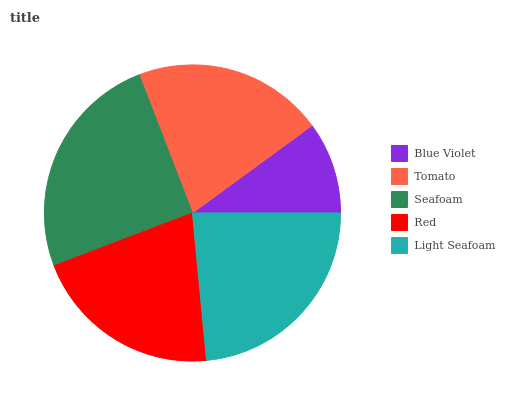Is Blue Violet the minimum?
Answer yes or no. Yes. Is Seafoam the maximum?
Answer yes or no. Yes. Is Tomato the minimum?
Answer yes or no. No. Is Tomato the maximum?
Answer yes or no. No. Is Tomato greater than Blue Violet?
Answer yes or no. Yes. Is Blue Violet less than Tomato?
Answer yes or no. Yes. Is Blue Violet greater than Tomato?
Answer yes or no. No. Is Tomato less than Blue Violet?
Answer yes or no. No. Is Tomato the high median?
Answer yes or no. Yes. Is Tomato the low median?
Answer yes or no. Yes. Is Red the high median?
Answer yes or no. No. Is Light Seafoam the low median?
Answer yes or no. No. 